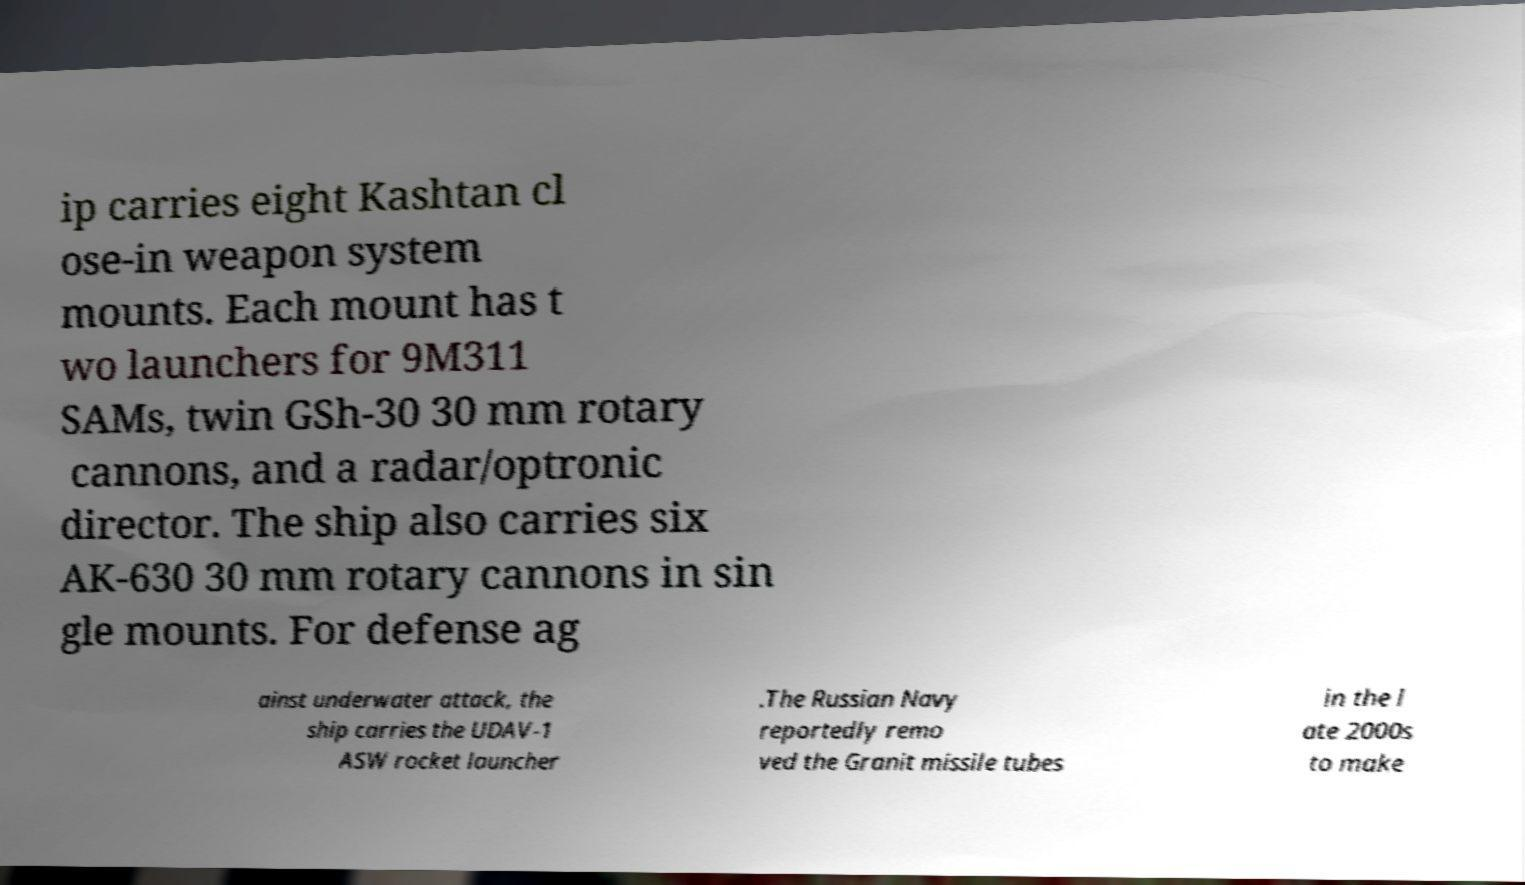Can you accurately transcribe the text from the provided image for me? ip carries eight Kashtan cl ose-in weapon system mounts. Each mount has t wo launchers for 9M311 SAMs, twin GSh-30 30 mm rotary cannons, and a radar/optronic director. The ship also carries six AK-630 30 mm rotary cannons in sin gle mounts. For defense ag ainst underwater attack, the ship carries the UDAV-1 ASW rocket launcher .The Russian Navy reportedly remo ved the Granit missile tubes in the l ate 2000s to make 